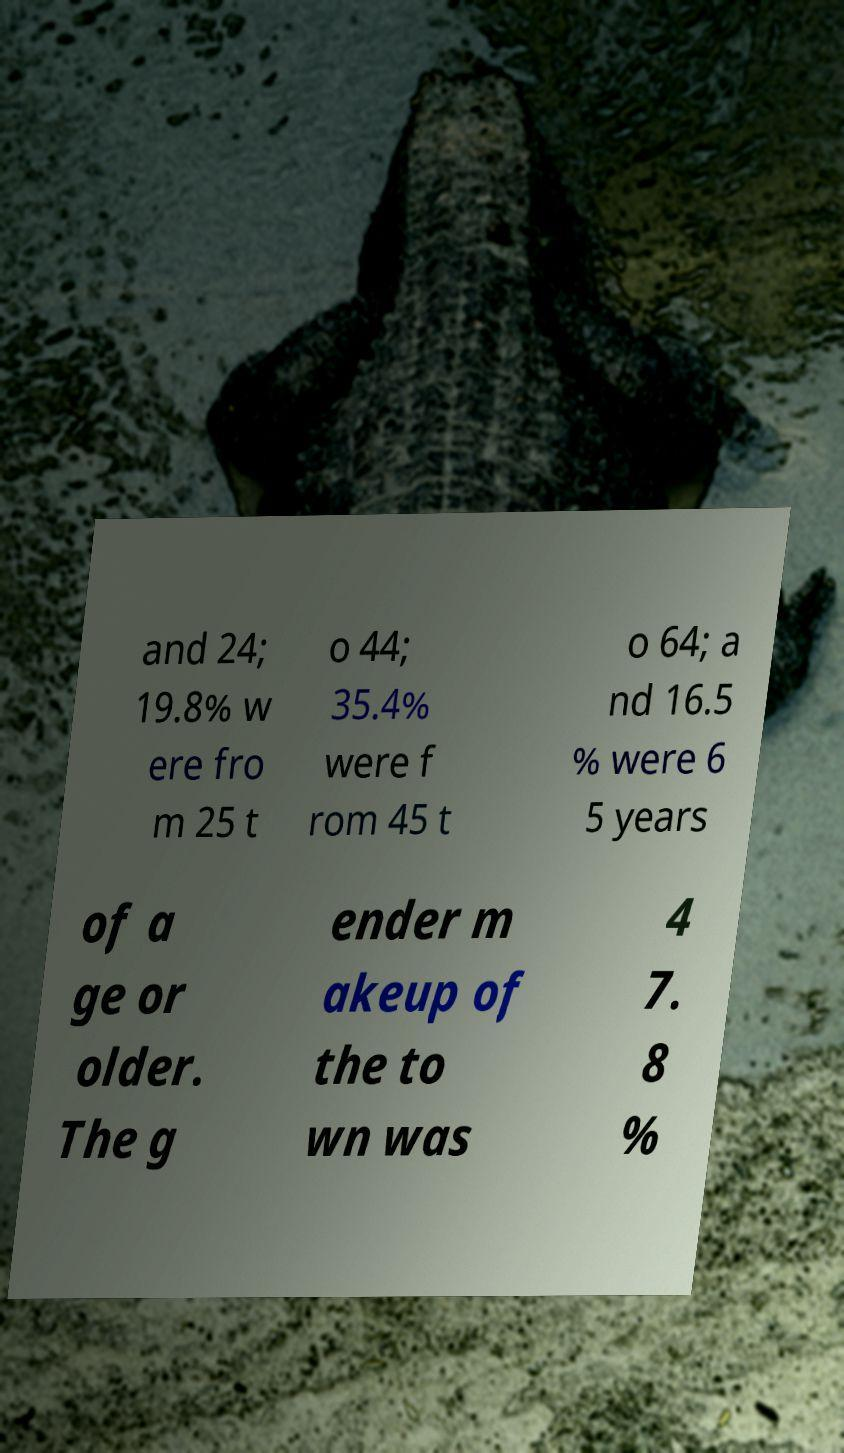Could you assist in decoding the text presented in this image and type it out clearly? and 24; 19.8% w ere fro m 25 t o 44; 35.4% were f rom 45 t o 64; a nd 16.5 % were 6 5 years of a ge or older. The g ender m akeup of the to wn was 4 7. 8 % 